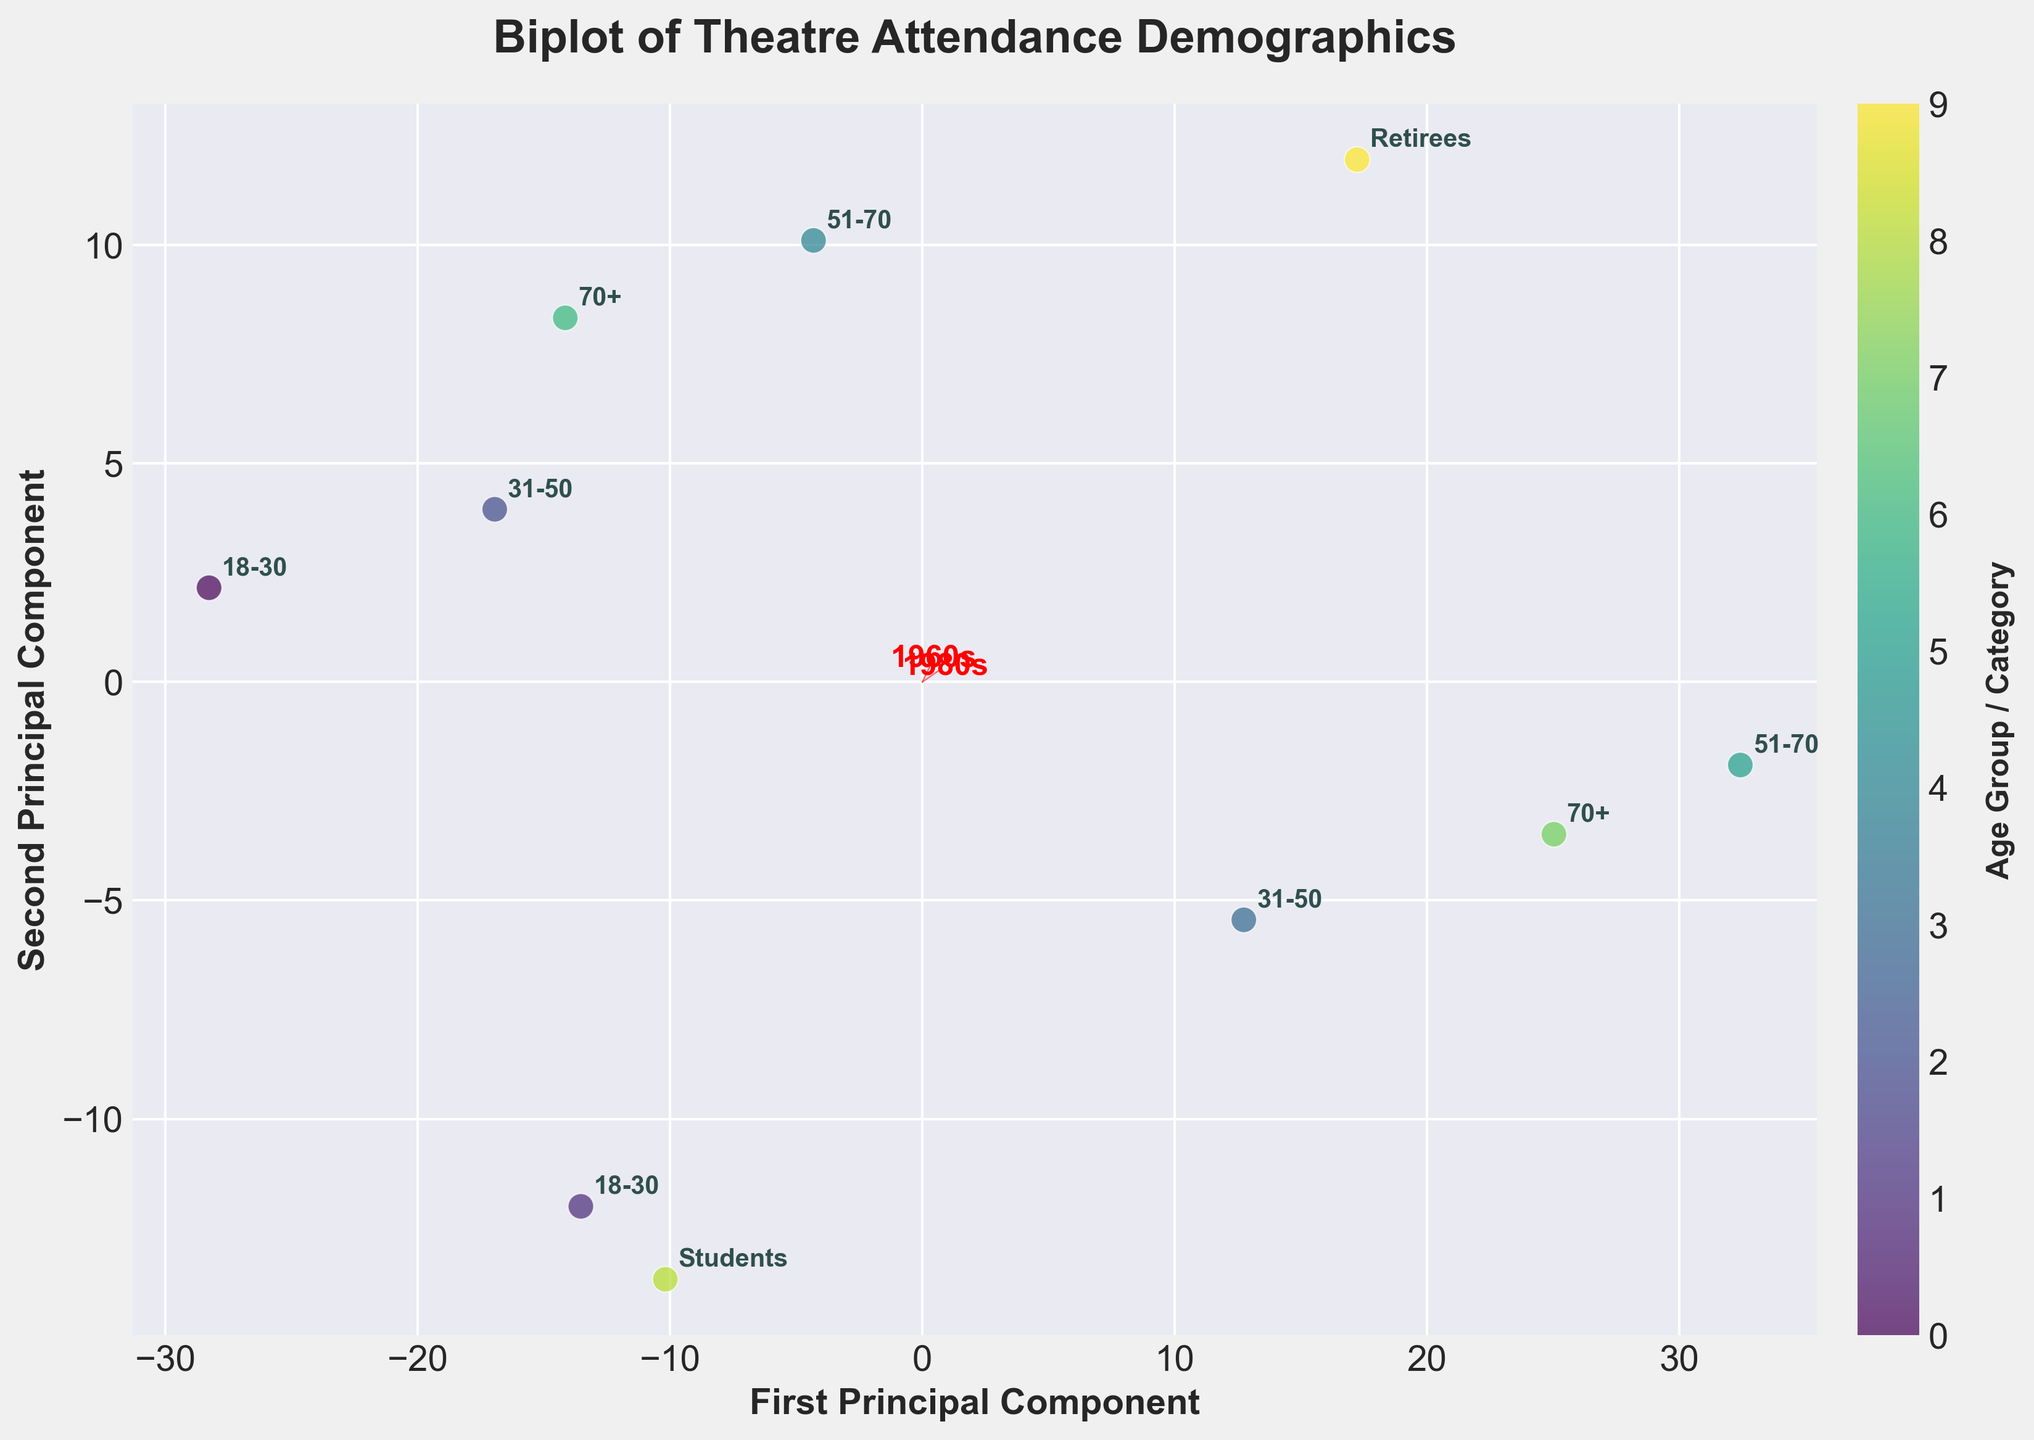How many age groups and categories are represented in the biplot? The biplot shows data points labeled with different age groups and categories. There are a total of 10 unique labels visible in the plot.
Answer: 10 Which age group shows the highest attendance in recent decades? By examining the data points in the biplot, we see the "51-70, High" age group is consistently placed higher along the axes representing recent decades, suggesting higher attendance.
Answer: 51-70, High What is the trend for low-income groups' theatre attendance from 1960s to 2020s? The feature vector representing periods ('1960s' to '2020s') combined with points for low-income groups showing a movement away from the origin suggests a decline over time.
Answer: Declining Compare the attendance change for retirees and students from the 1960s to the 2020s. By checking the positions of 'Retirees' and 'Students' data points on the biplot over the decades, we notice 'Retirees' attendance decreases while 'Students' attendance increases.
Answer: Retirees: Decreasing; Students: Increasing Which socioeconomic factor has the most noticeable change in the biplot? High-income groups, particularly noticeable in the “51-70, High” category, show an increasing trend over time, suggesting socioeconomic status significantly influences attendance.
Answer: High-income Is there a correlation between income level and theatre attendance change over decades? The biplot's feature vectors and the positioning of data points for high-income and low-income groups indicate high-income groups have increasing attendance, while low-income groups show a decline, suggesting a correlation.
Answer: Yes Are younger age groups (18-30) attending more theatre as years go by? Observing the movement of data points for “18-30, Low” and “18-30, High” towards the more recent decades shows a mixed trend: higher attendance for high-income but lower for low-income groups.
Answer: Mixed Between low and high-income levels, which one has a steeper attendance decline over the decades? By analyzing the position and trend of the 'Low' income group data points, particularly in the "31-50, Low" and "51-70, Low" categories, we observe a steeper decline compared to high-income groups.
Answer: Low-income How do the 1960s and 2020s contribute to the first principal component? The arrows and labels associated with '1960s' and '2020s' feature vectors show significant contributions along the first principal component axis, impacting the directionality of points.
Answer: Significant What can be inferred about theatre attendance for "70+, High" over the decades? The biplot shows that the "70+, High" category remains relatively stable and higher along the axes over the decades, suggesting consistent or slight increase in attendance.
Answer: Stable/Increased 